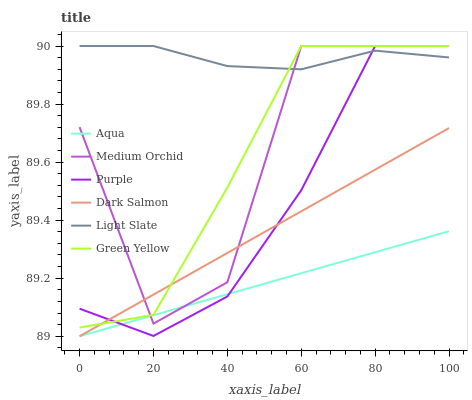Does Aqua have the minimum area under the curve?
Answer yes or no. Yes. Does Light Slate have the maximum area under the curve?
Answer yes or no. Yes. Does Medium Orchid have the minimum area under the curve?
Answer yes or no. No. Does Medium Orchid have the maximum area under the curve?
Answer yes or no. No. Is Aqua the smoothest?
Answer yes or no. Yes. Is Medium Orchid the roughest?
Answer yes or no. Yes. Is Medium Orchid the smoothest?
Answer yes or no. No. Is Aqua the roughest?
Answer yes or no. No. Does Aqua have the lowest value?
Answer yes or no. Yes. Does Medium Orchid have the lowest value?
Answer yes or no. No. Does Green Yellow have the highest value?
Answer yes or no. Yes. Does Aqua have the highest value?
Answer yes or no. No. Is Dark Salmon less than Light Slate?
Answer yes or no. Yes. Is Light Slate greater than Dark Salmon?
Answer yes or no. Yes. Does Aqua intersect Dark Salmon?
Answer yes or no. Yes. Is Aqua less than Dark Salmon?
Answer yes or no. No. Is Aqua greater than Dark Salmon?
Answer yes or no. No. Does Dark Salmon intersect Light Slate?
Answer yes or no. No. 